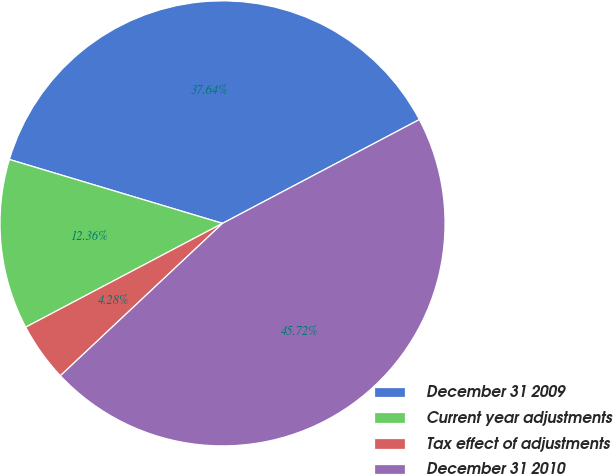Convert chart to OTSL. <chart><loc_0><loc_0><loc_500><loc_500><pie_chart><fcel>December 31 2009<fcel>Current year adjustments<fcel>Tax effect of adjustments<fcel>December 31 2010<nl><fcel>37.64%<fcel>12.36%<fcel>4.28%<fcel>45.72%<nl></chart> 